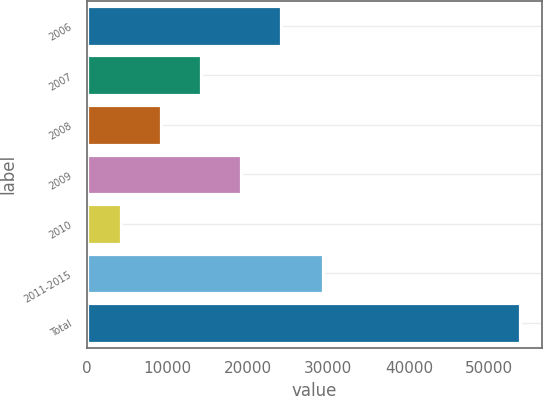<chart> <loc_0><loc_0><loc_500><loc_500><bar_chart><fcel>2006<fcel>2007<fcel>2008<fcel>2009<fcel>2010<fcel>2011-2015<fcel>Total<nl><fcel>24091.6<fcel>14180.8<fcel>9225.4<fcel>19136.2<fcel>4270<fcel>29344<fcel>53824<nl></chart> 